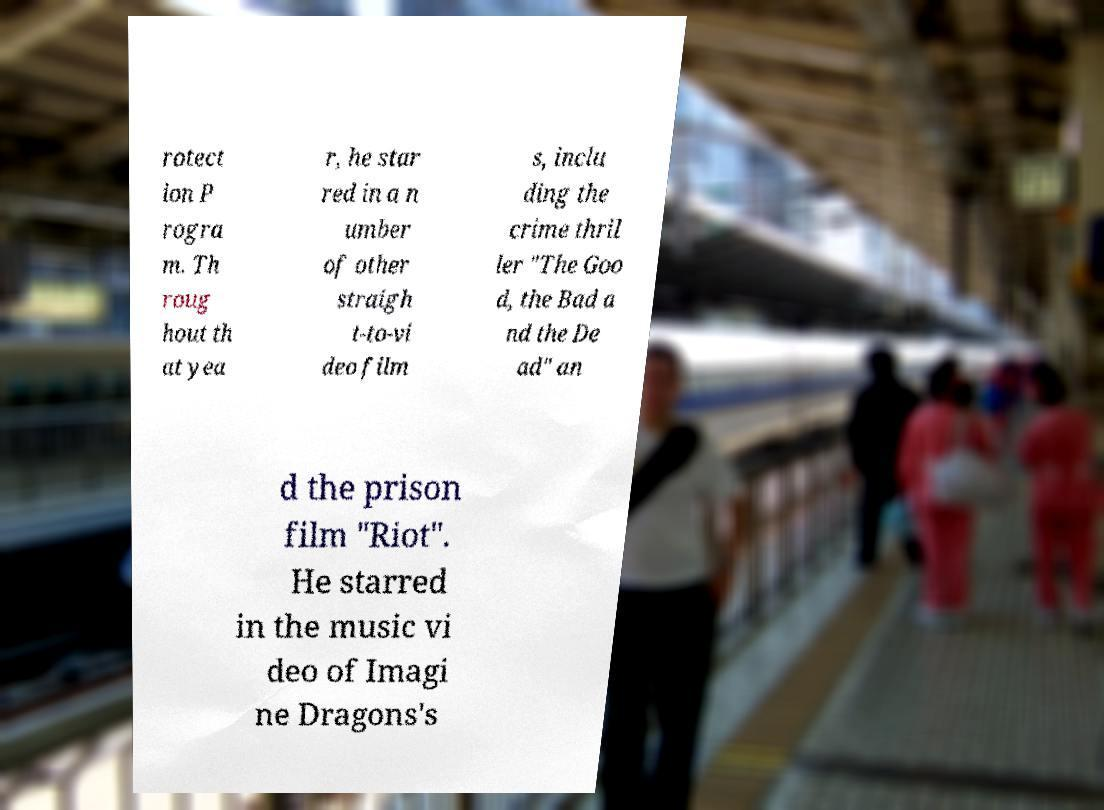Please read and relay the text visible in this image. What does it say? rotect ion P rogra m. Th roug hout th at yea r, he star red in a n umber of other straigh t-to-vi deo film s, inclu ding the crime thril ler "The Goo d, the Bad a nd the De ad" an d the prison film "Riot". He starred in the music vi deo of Imagi ne Dragons's 